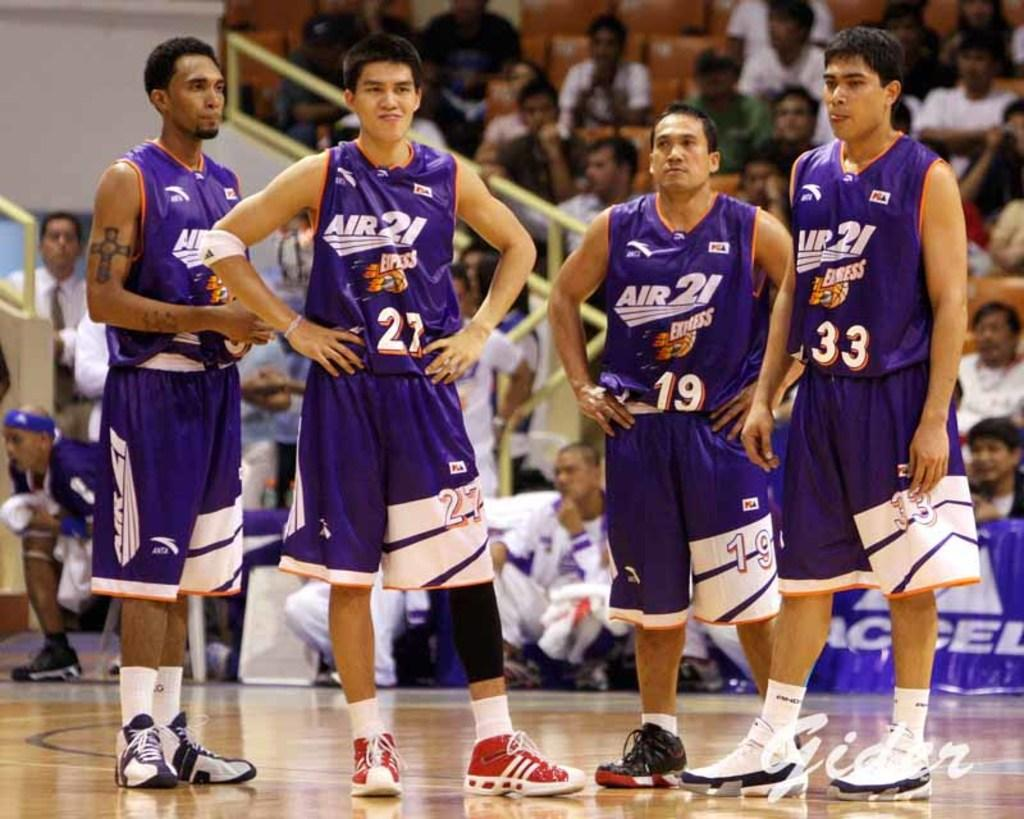How many people are standing on the floor in the image? There are four persons standing on the floor. What are the people in the background doing? There is a group of people sitting on chairs in the background. What can be seen hanging or displayed in the image? There is a banner visible in the image. What type of bushes can be seen growing near the wall in the image? There are no bushes visible in the image; only a wall is present. What smell can be detected in the image? There is no mention of smell in the image, so it cannot be detected. 